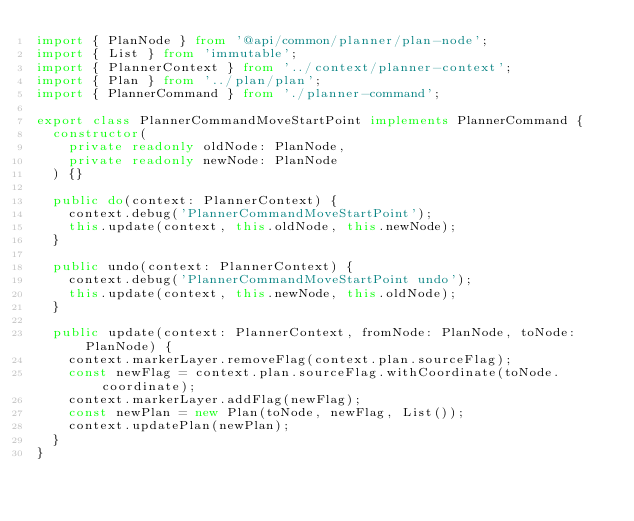<code> <loc_0><loc_0><loc_500><loc_500><_TypeScript_>import { PlanNode } from '@api/common/planner/plan-node';
import { List } from 'immutable';
import { PlannerContext } from '../context/planner-context';
import { Plan } from '../plan/plan';
import { PlannerCommand } from './planner-command';

export class PlannerCommandMoveStartPoint implements PlannerCommand {
  constructor(
    private readonly oldNode: PlanNode,
    private readonly newNode: PlanNode
  ) {}

  public do(context: PlannerContext) {
    context.debug('PlannerCommandMoveStartPoint');
    this.update(context, this.oldNode, this.newNode);
  }

  public undo(context: PlannerContext) {
    context.debug('PlannerCommandMoveStartPoint undo');
    this.update(context, this.newNode, this.oldNode);
  }

  public update(context: PlannerContext, fromNode: PlanNode, toNode: PlanNode) {
    context.markerLayer.removeFlag(context.plan.sourceFlag);
    const newFlag = context.plan.sourceFlag.withCoordinate(toNode.coordinate);
    context.markerLayer.addFlag(newFlag);
    const newPlan = new Plan(toNode, newFlag, List());
    context.updatePlan(newPlan);
  }
}
</code> 